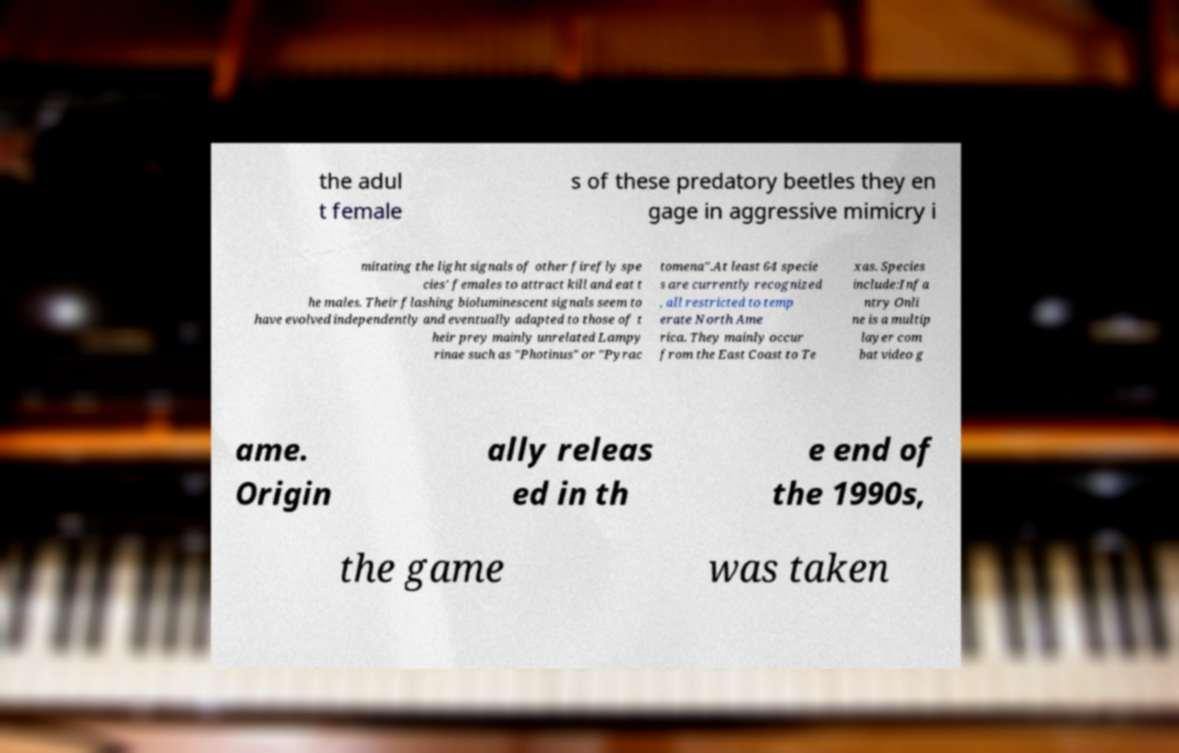Please read and relay the text visible in this image. What does it say? the adul t female s of these predatory beetles they en gage in aggressive mimicry i mitating the light signals of other firefly spe cies' females to attract kill and eat t he males. Their flashing bioluminescent signals seem to have evolved independently and eventually adapted to those of t heir prey mainly unrelated Lampy rinae such as "Photinus" or "Pyrac tomena".At least 64 specie s are currently recognized , all restricted to temp erate North Ame rica. They mainly occur from the East Coast to Te xas. Species include:Infa ntry Onli ne is a multip layer com bat video g ame. Origin ally releas ed in th e end of the 1990s, the game was taken 